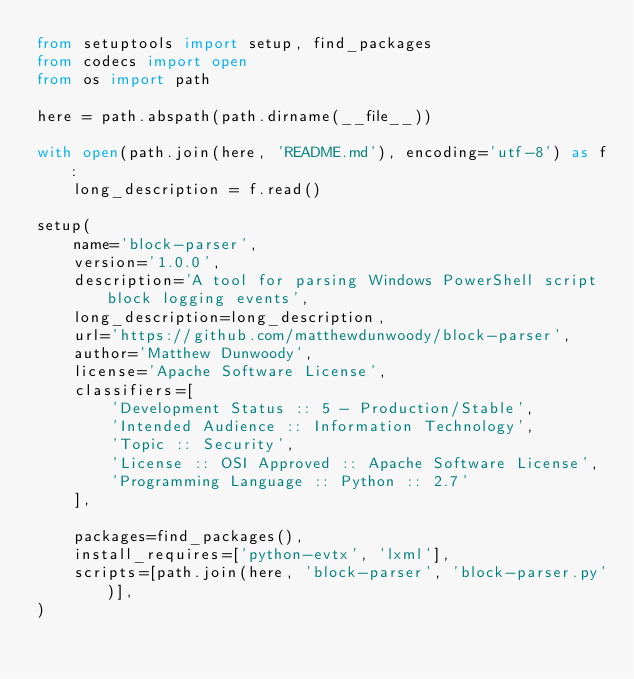<code> <loc_0><loc_0><loc_500><loc_500><_Python_>from setuptools import setup, find_packages
from codecs import open
from os import path

here = path.abspath(path.dirname(__file__))

with open(path.join(here, 'README.md'), encoding='utf-8') as f:
    long_description = f.read()

setup(
    name='block-parser',
    version='1.0.0',
    description='A tool for parsing Windows PowerShell script block logging events',
    long_description=long_description,
    url='https://github.com/matthewdunwoody/block-parser',
    author='Matthew Dunwoody',
    license='Apache Software License',
    classifiers=[
        'Development Status :: 5 - Production/Stable',
        'Intended Audience :: Information Technology',
        'Topic :: Security',
        'License :: OSI Approved :: Apache Software License',
        'Programming Language :: Python :: 2.7'
    ],

    packages=find_packages(),
    install_requires=['python-evtx', 'lxml'],
    scripts=[path.join(here, 'block-parser', 'block-parser.py')],
)
</code> 